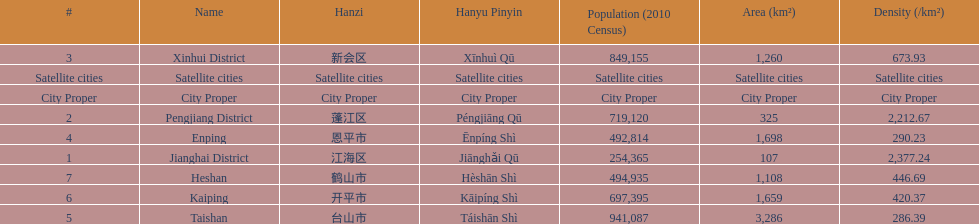Which area under the satellite cities has the most in population? Taishan. 